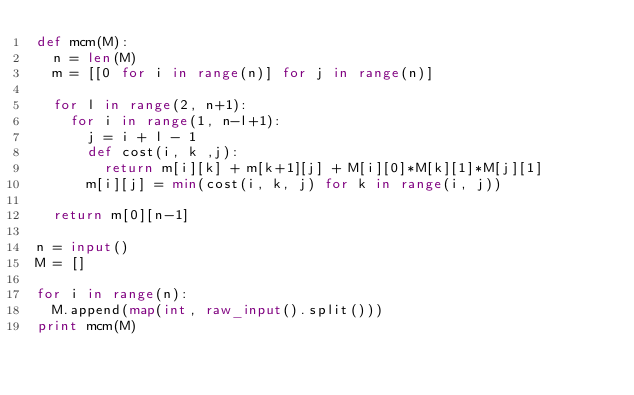<code> <loc_0><loc_0><loc_500><loc_500><_Python_>def mcm(M):
  n = len(M)
  m = [[0 for i in range(n)] for j in range(n)]
  
  for l in range(2, n+1):
    for i in range(1, n-l+1):
      j = i + l - 1
      def cost(i, k ,j):
        return m[i][k] + m[k+1][j] + M[i][0]*M[k][1]*M[j][1]
      m[i][j] = min(cost(i, k, j) for k in range(i, j))
  
  return m[0][n-1]

n = input()
M = []

for i in range(n):
  M.append(map(int, raw_input().split()))
print mcm(M)</code> 